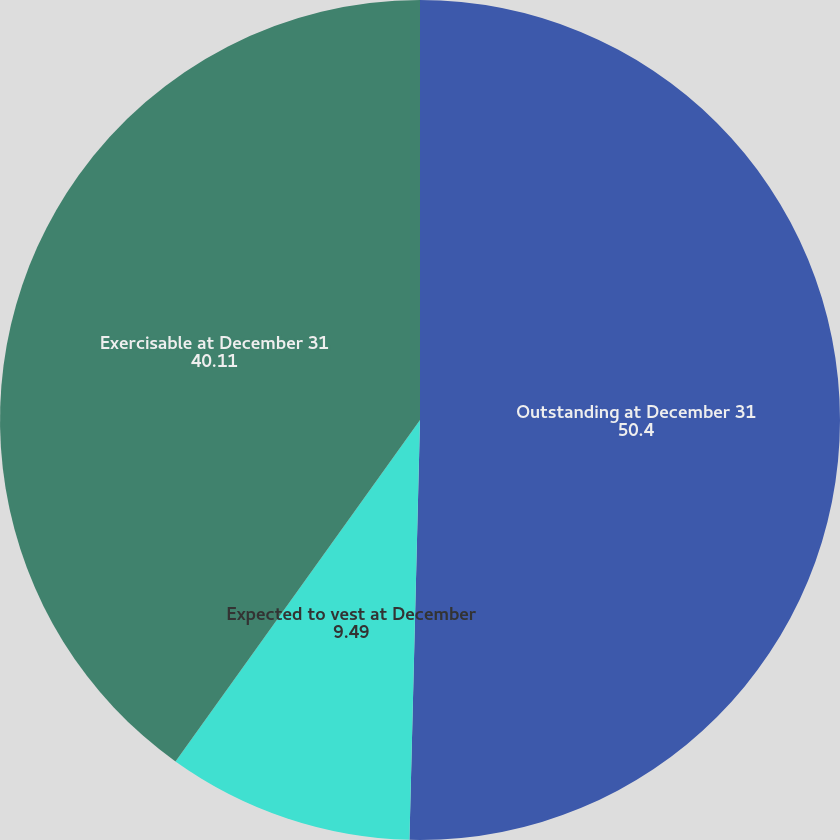Convert chart to OTSL. <chart><loc_0><loc_0><loc_500><loc_500><pie_chart><fcel>Outstanding at December 31<fcel>Expected to vest at December<fcel>Exercisable at December 31<nl><fcel>50.4%<fcel>9.49%<fcel>40.11%<nl></chart> 